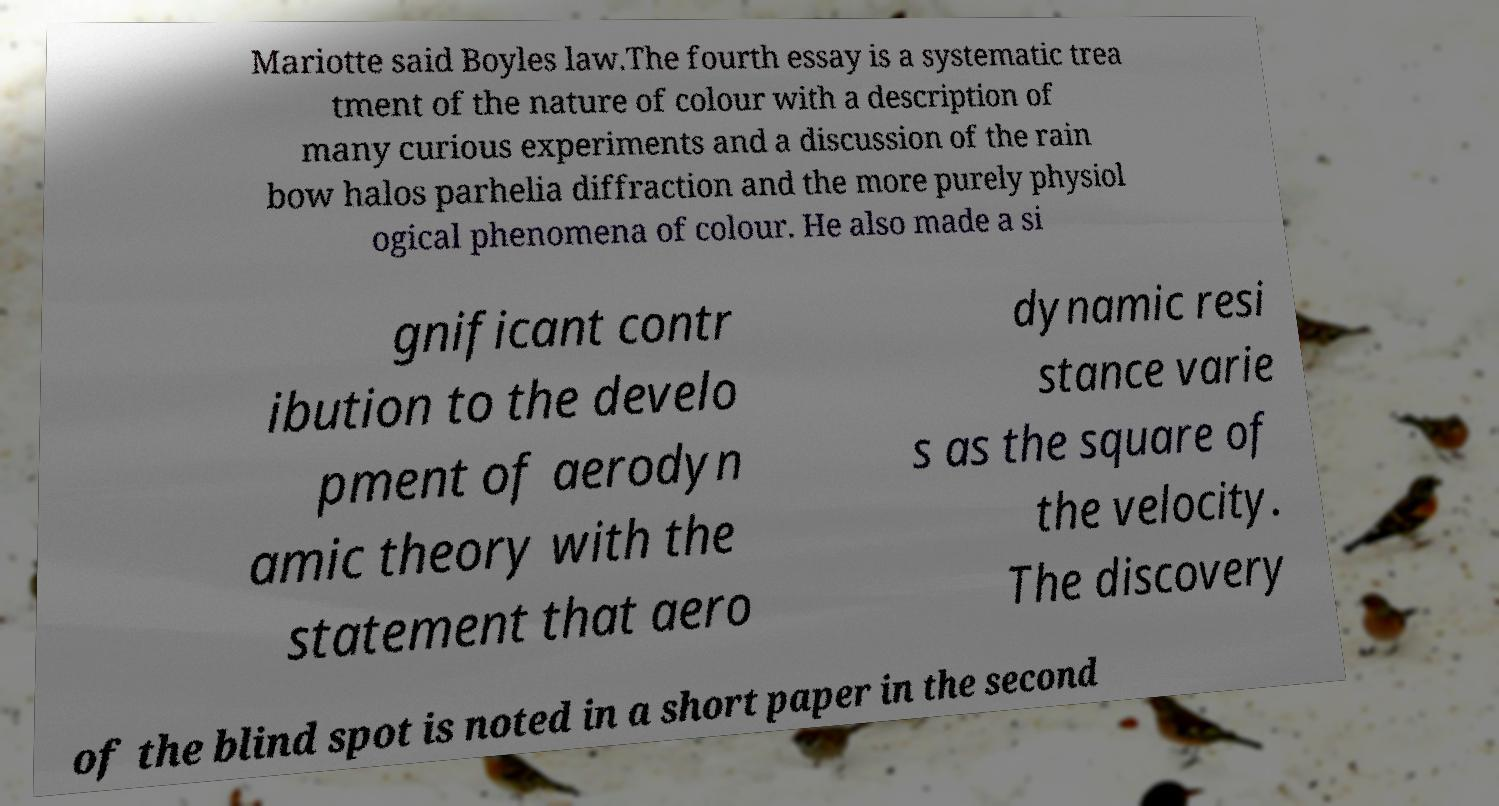Could you assist in decoding the text presented in this image and type it out clearly? Mariotte said Boyles law.The fourth essay is a systematic trea tment of the nature of colour with a description of many curious experiments and a discussion of the rain bow halos parhelia diffraction and the more purely physiol ogical phenomena of colour. He also made a si gnificant contr ibution to the develo pment of aerodyn amic theory with the statement that aero dynamic resi stance varie s as the square of the velocity. The discovery of the blind spot is noted in a short paper in the second 